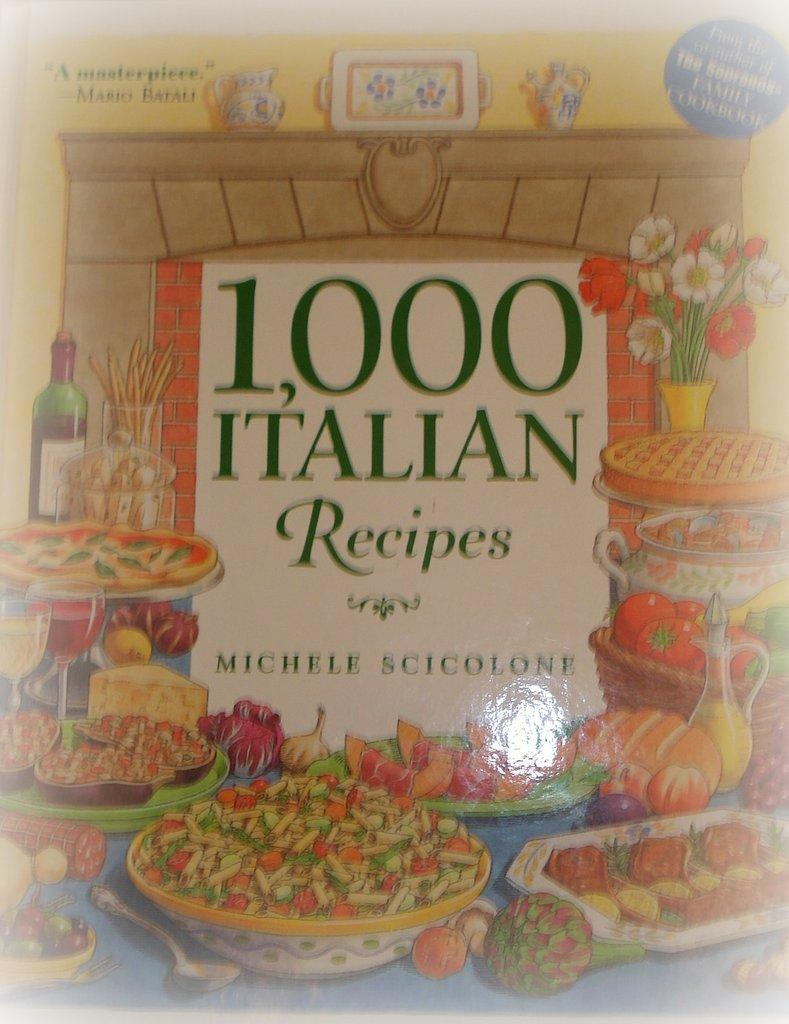<image>
Present a compact description of the photo's key features. A book of recipes is written by Michele Scicolone. 